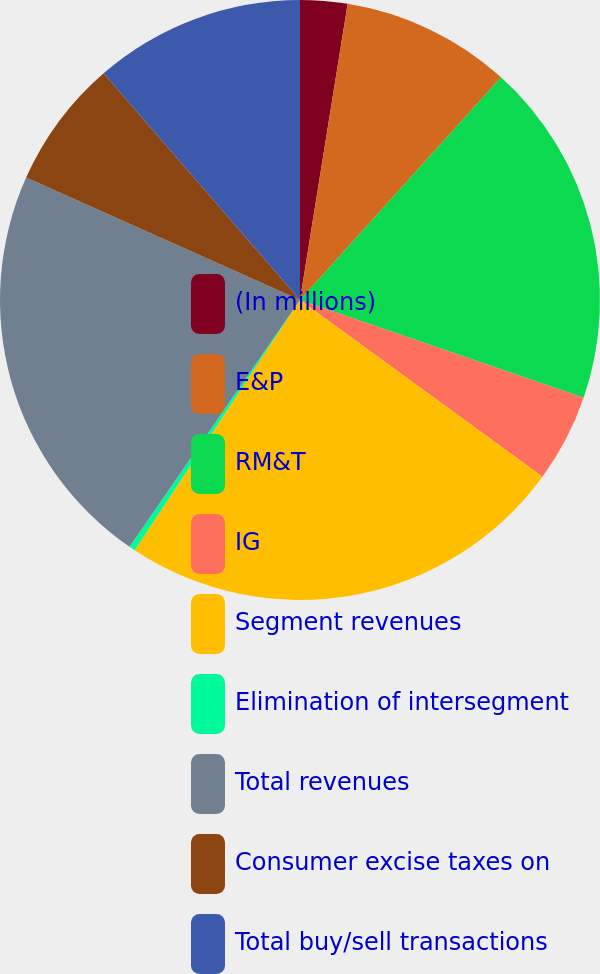Convert chart. <chart><loc_0><loc_0><loc_500><loc_500><pie_chart><fcel>(In millions)<fcel>E&P<fcel>RM&T<fcel>IG<fcel>Segment revenues<fcel>Elimination of intersegment<fcel>Total revenues<fcel>Consumer excise taxes on<fcel>Total buy/sell transactions<nl><fcel>2.54%<fcel>9.15%<fcel>18.59%<fcel>4.74%<fcel>24.27%<fcel>0.33%<fcel>22.07%<fcel>6.95%<fcel>11.36%<nl></chart> 